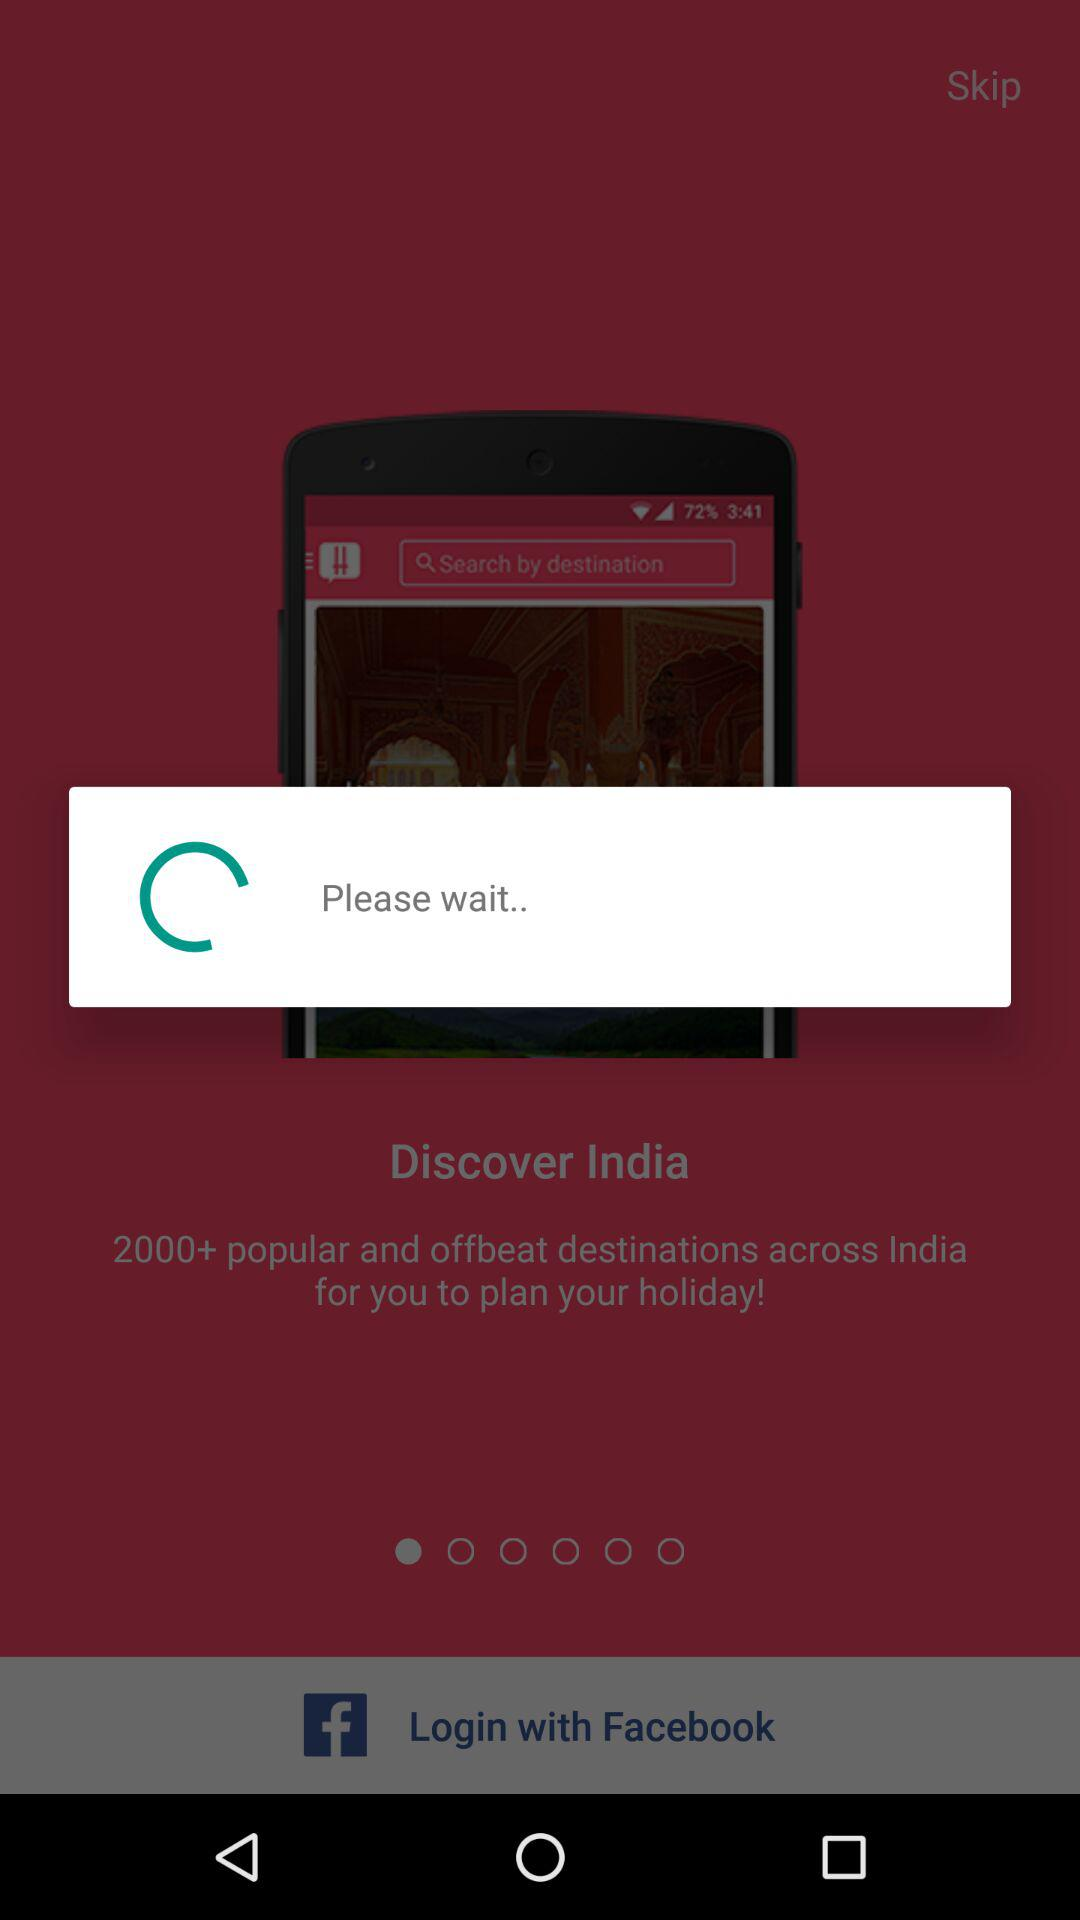Through what account can logging in be done? Logging can be done through "Facebook" account. 